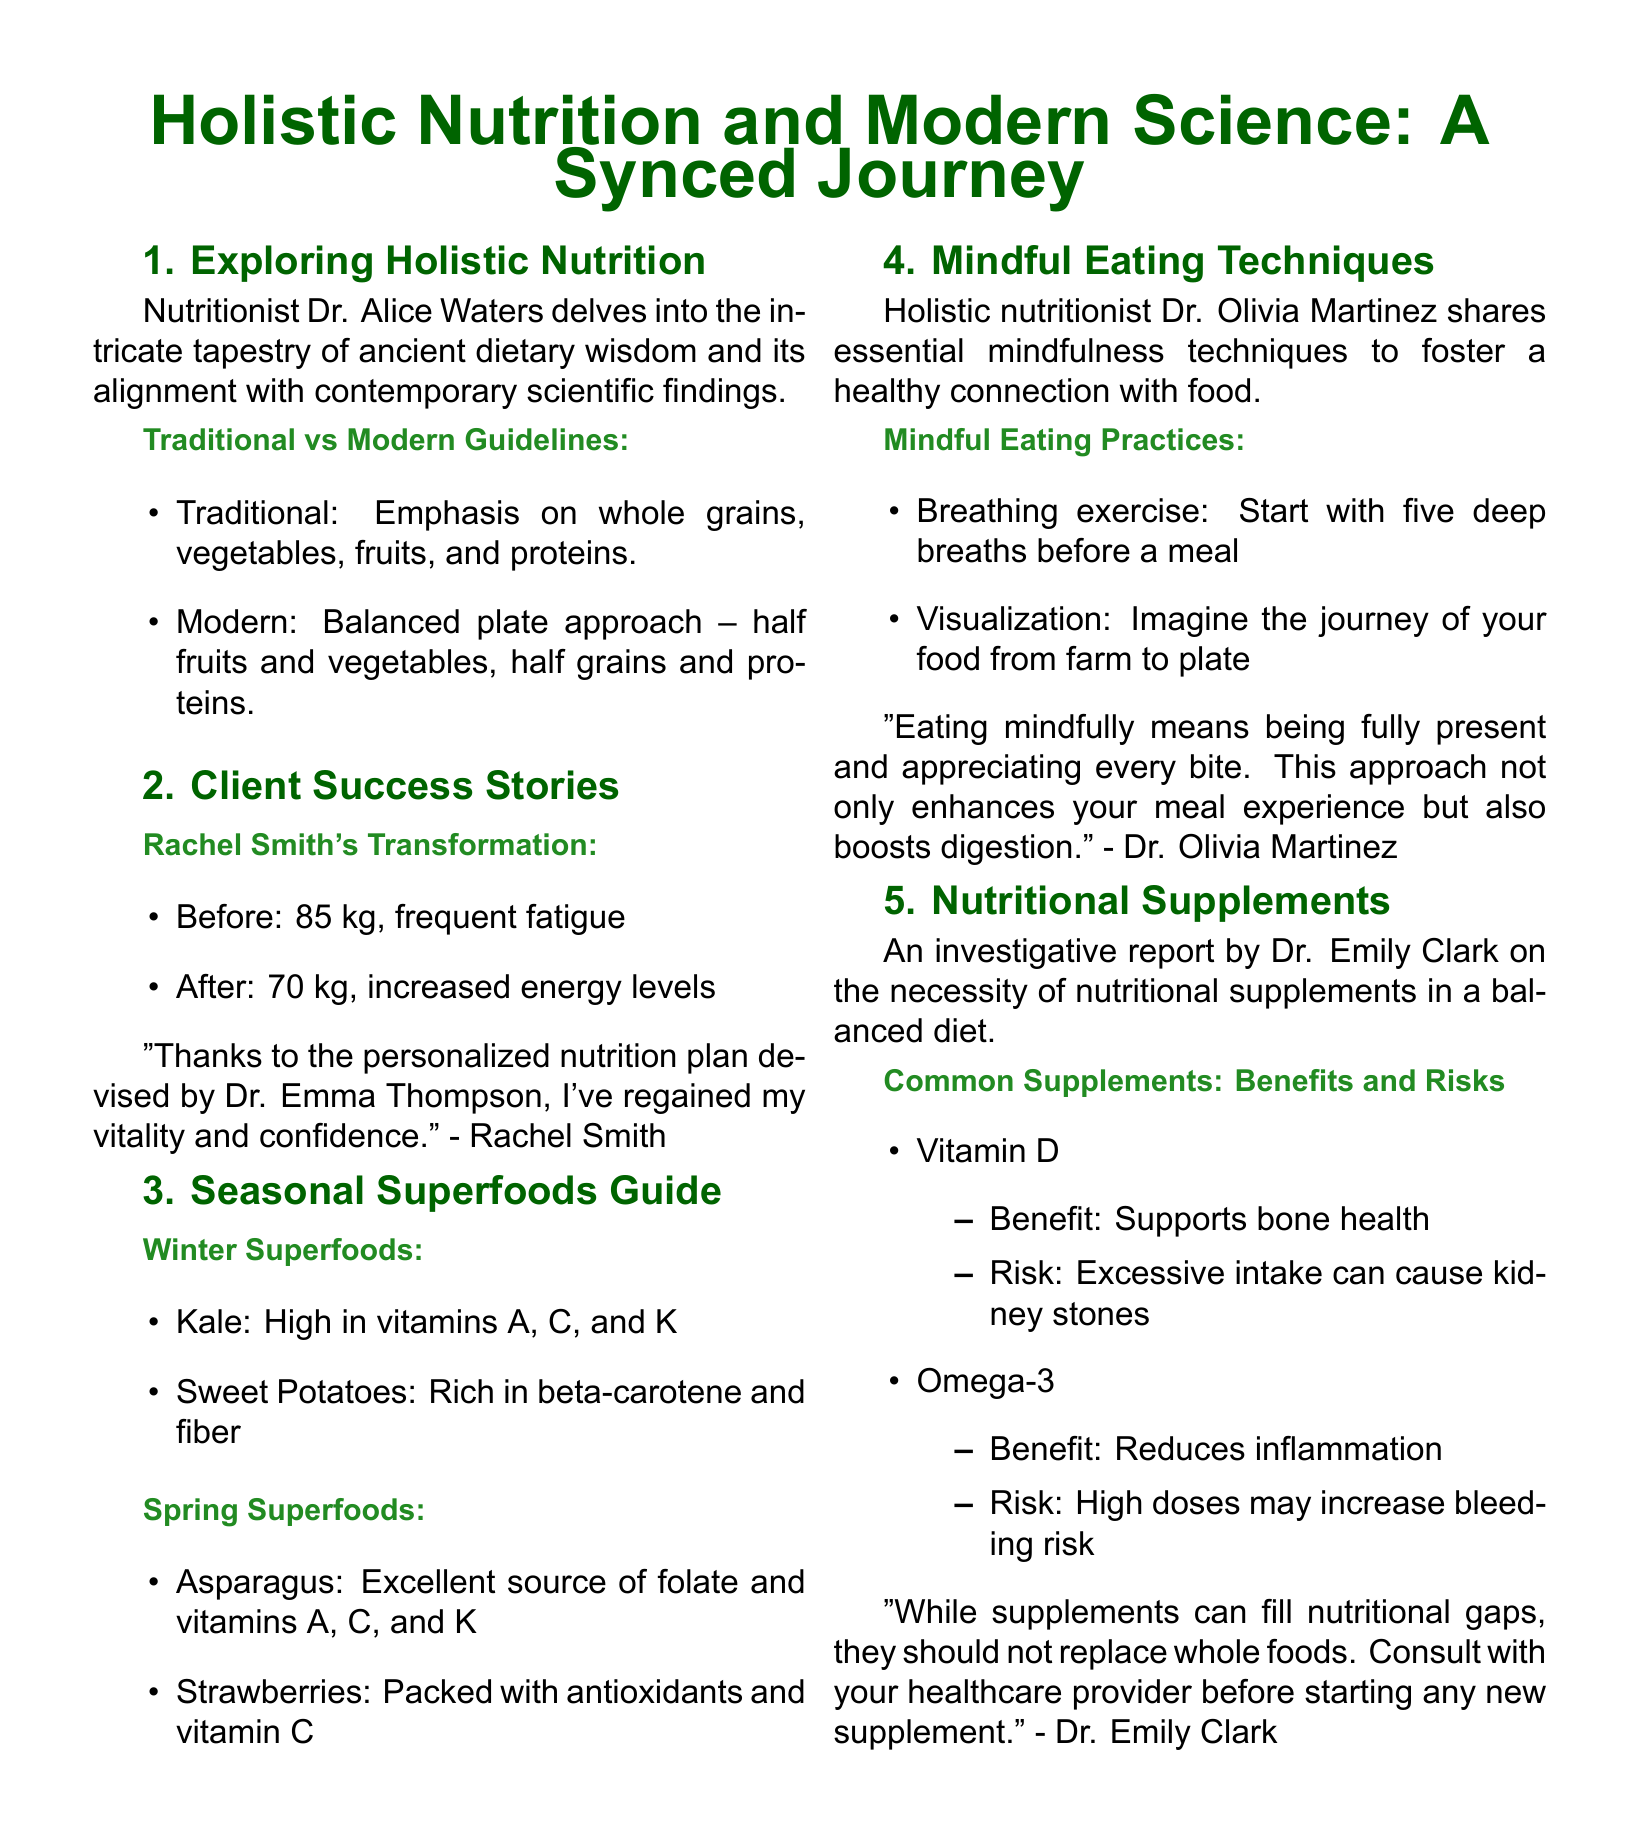What is the title of the article? The title of the article is prominently stated in the document, introducing the theme of the content.
Answer: Holistic Nutrition and Modern Science: A Synced Journey Who is the nutritionist featured in the exploration of holistic nutrition? The document names Dr. Alice Waters as the nutritionist discussing ancient dietary wisdom and modern science.
Answer: Dr. Alice Waters What was Rachel Smith's weight before the personal nutrition plan? The document provides Rachel Smith's weight before starting her personalized nutrition plan as part of her success story.
Answer: 85 kg What are two winter superfoods mentioned? The guide lists specific superfoods that are beneficial in winter and provides their health benefits.
Answer: Kale, Sweet Potatoes What breathing technique is suggested before meals? The document offers mindfulness practices, including a specific breathing exercise to practice before eating.
Answer: Five deep breaths What is the potential risk of excessive Vitamin D intake? An investigation in the document highlights various nutritional supplements and their associated risks and benefits.
Answer: Kidney stones What is the primary focus of mindful eating according to Dr. Olivia Martinez? The document captures Dr. Olivia Martinez's insight on the essence of mindful eating and its impact on health.
Answer: Being fully present Which supplement is noted for reducing inflammation? The document investigates common nutritional supplements, providing their benefits, one of which includes inflammation reduction.
Answer: Omega-3 